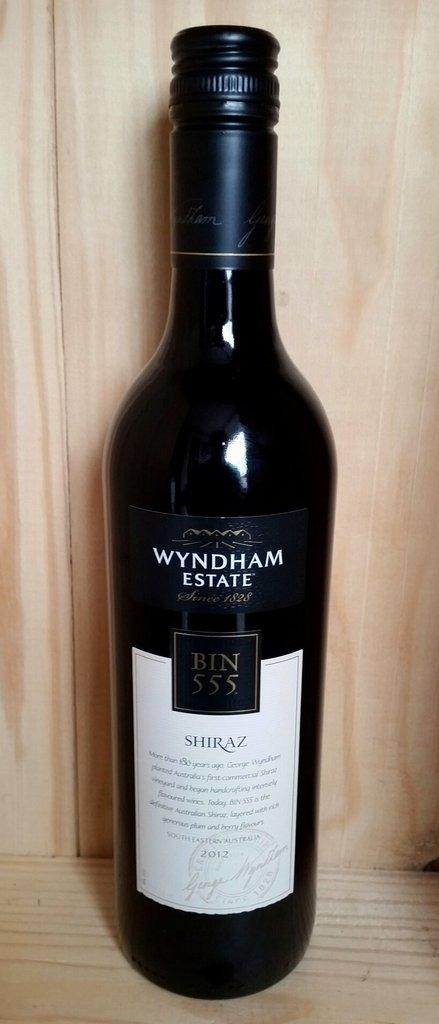<image>
Provide a brief description of the given image. A bottle of shiraz from Wyndham Estate sits in a wooden box. 